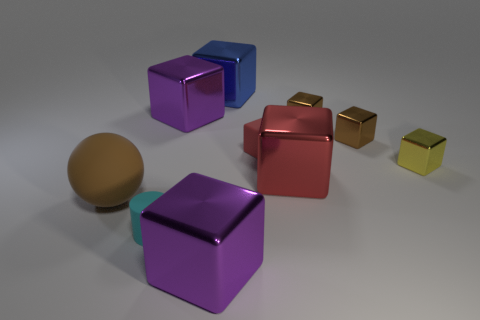Subtract all tiny yellow cubes. How many cubes are left? 7 Subtract all purple cubes. How many cubes are left? 6 Subtract all purple cubes. Subtract all purple cylinders. How many cubes are left? 6 Subtract 1 cyan cylinders. How many objects are left? 9 Subtract all cylinders. How many objects are left? 9 Subtract all small objects. Subtract all big rubber objects. How many objects are left? 4 Add 9 big red objects. How many big red objects are left? 10 Add 7 metal spheres. How many metal spheres exist? 7 